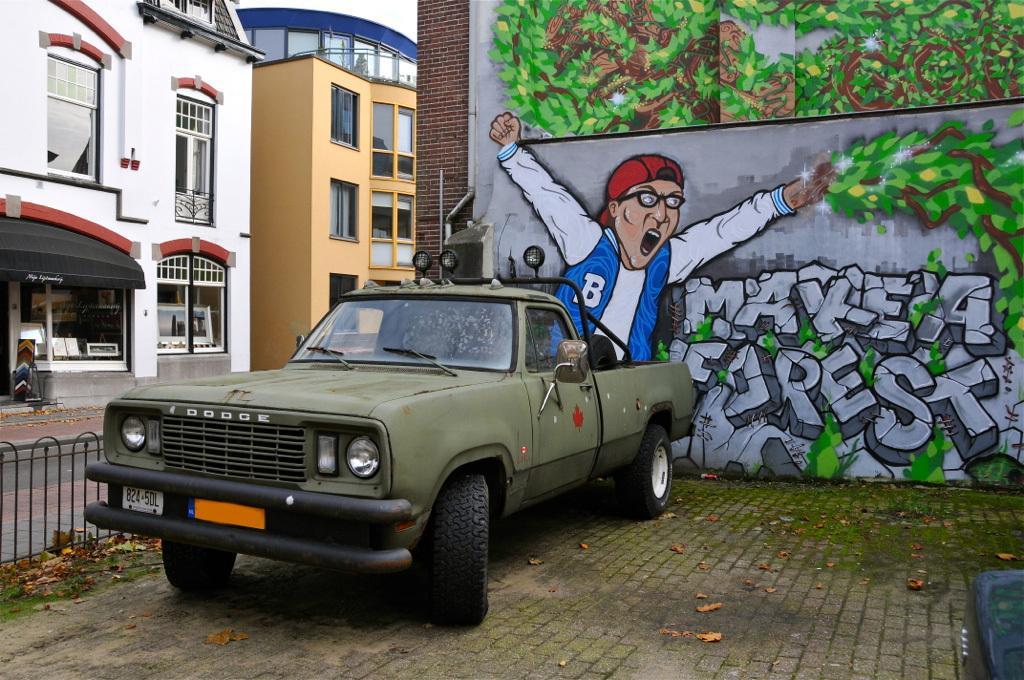Could you give a brief overview of what you see in this image? In this picture we can see a fence, vehicle and dry leaves on the path. There is some algae on this path. There is some painting and a text on the wall. We can see a few buildings and windows. 